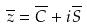<formula> <loc_0><loc_0><loc_500><loc_500>\overline { z } = \overline { C } + i \overline { S }</formula> 